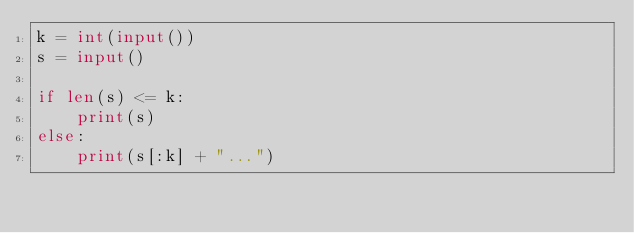<code> <loc_0><loc_0><loc_500><loc_500><_Python_>k = int(input())
s = input()

if len(s) <= k:
    print(s)
else:
    print(s[:k] + "...")</code> 